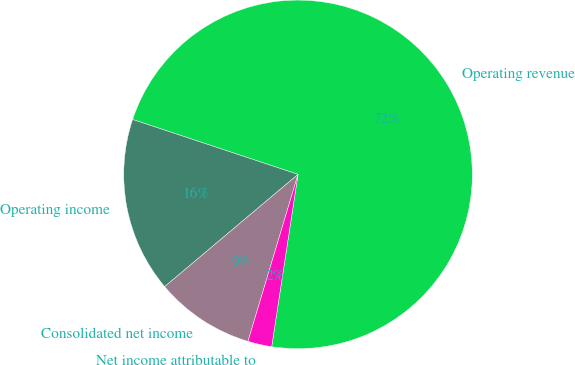<chart> <loc_0><loc_0><loc_500><loc_500><pie_chart><fcel>Operating revenue<fcel>Operating income<fcel>Consolidated net income<fcel>Net income attributable to<nl><fcel>72.32%<fcel>16.24%<fcel>9.23%<fcel>2.22%<nl></chart> 